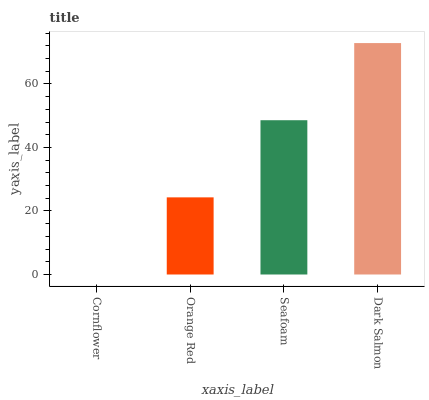Is Orange Red the minimum?
Answer yes or no. No. Is Orange Red the maximum?
Answer yes or no. No. Is Orange Red greater than Cornflower?
Answer yes or no. Yes. Is Cornflower less than Orange Red?
Answer yes or no. Yes. Is Cornflower greater than Orange Red?
Answer yes or no. No. Is Orange Red less than Cornflower?
Answer yes or no. No. Is Seafoam the high median?
Answer yes or no. Yes. Is Orange Red the low median?
Answer yes or no. Yes. Is Dark Salmon the high median?
Answer yes or no. No. Is Seafoam the low median?
Answer yes or no. No. 